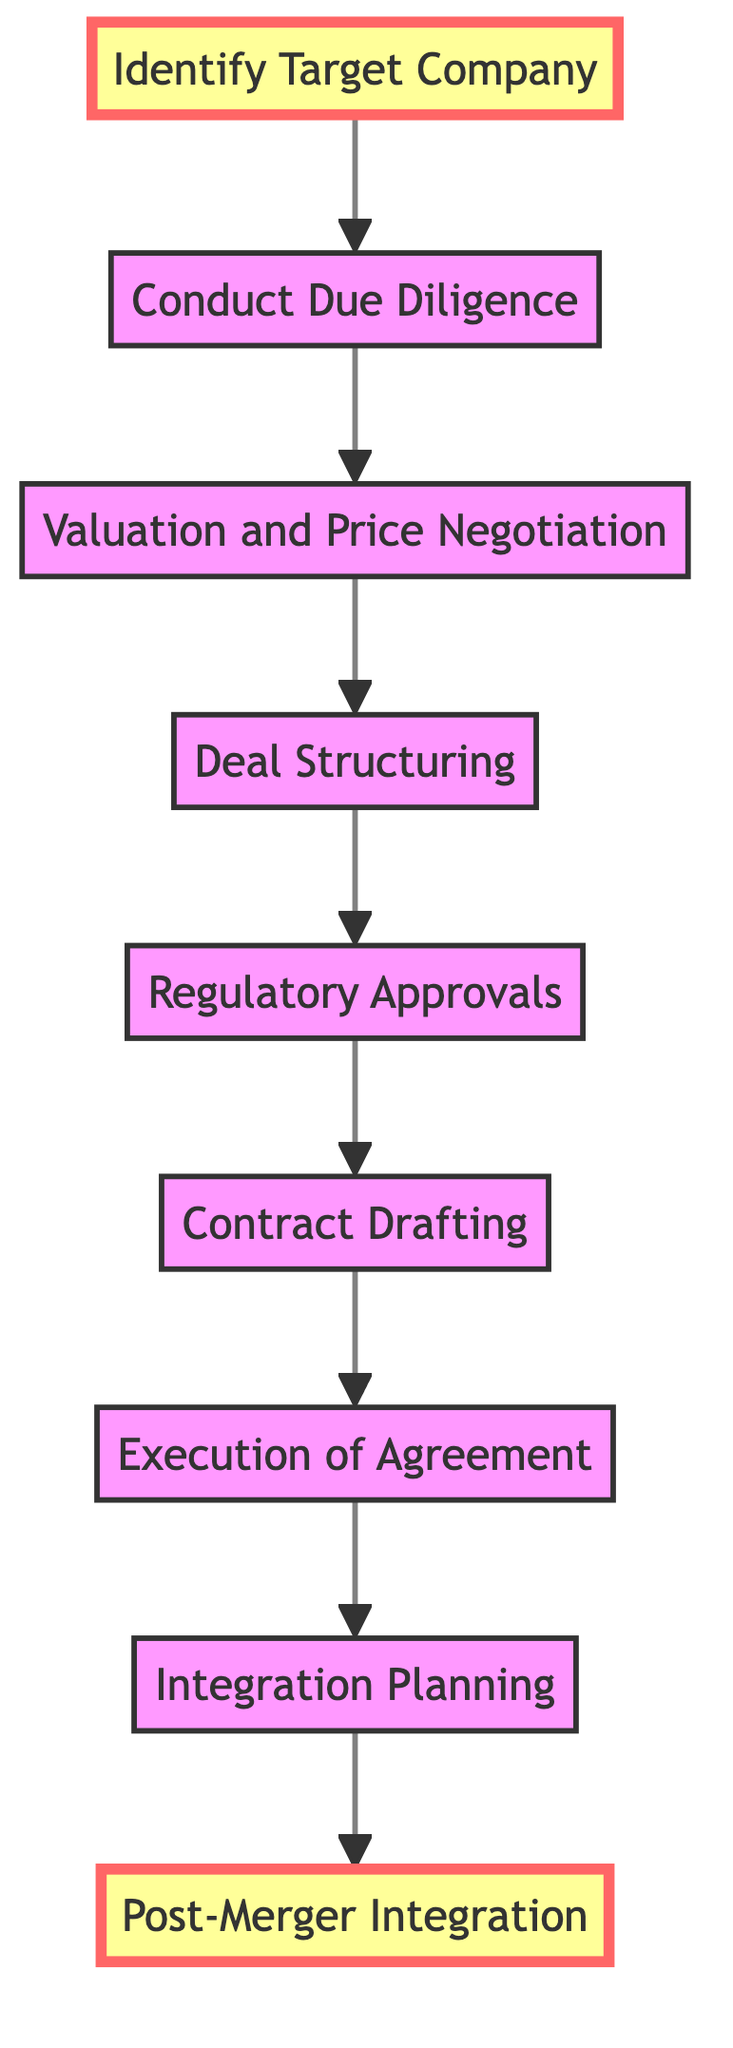What is the initial step in the process? The diagram starts with the "Identify Target Company" node, which represents the first step in cross-border mergers and acquisitions.
Answer: Identify Target Company How many nodes are there in the diagram? By counting the distinct steps mentioned in the diagram, we find a total of 9 nodes representing various phases of the process.
Answer: 9 What is the final step in the process? The diagram ends with "Post-Merger Integration," which indicates the concluding phase of the entire merger and acquisition procedure.
Answer: Post-Merger Integration Which step follows 'Due Diligence'? According to the connections shown in the diagram, the step that comes immediately after 'Conduct Due Diligence' is 'Valuation and Price Negotiation.'
Answer: Valuation and Price Negotiation What is the step before 'Contract Drafting'? The diagram illustrates that the step preceding 'Contract Drafting' is 'Regulatory Approvals,' indicating that all necessary approvals are secured before drafting the contracts.
Answer: Regulatory Approvals How many direct connections does 'Execution of Agreement' have? The 'Execution of Agreement' node connects to one subsequent step, 'Integration Planning,' indicating it has a single direct outgoing connection.
Answer: 1 Which two steps are connected directly to 'Deal Structuring'? The node 'Deal Structuring' is directly connected to 'Valuation and Price Negotiation' as its predecessor, and 'Regulatory Approvals' as its successor in the sequence of steps.
Answer: Valuation and Price Negotiation, Regulatory Approvals What is the relationship between 'Identify Target Company' and 'Post-Merger Integration'? The relationship is sequential; 'Identify Target Company' is the starting point, while 'Post-Merger Integration' is the last step, indicating that all other steps in between must be completed in order to reach this final phase.
Answer: Sequential relationship Which node has the most steps leading to it? The node 'Contract Drafting' has two steps leading to it: 'Regulatory Approvals' precedes it, while 'Execution of Agreement' follows it, indicating it is a critical juncture in the process.
Answer: 2 